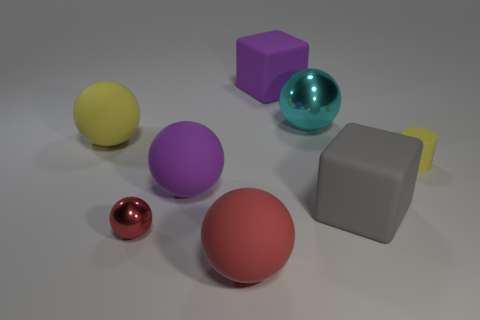Subtract all purple spheres. How many spheres are left? 4 Subtract all red rubber balls. How many balls are left? 4 Add 1 tiny yellow rubber blocks. How many objects exist? 9 Subtract all gray balls. Subtract all yellow cubes. How many balls are left? 5 Subtract all spheres. How many objects are left? 3 Add 3 gray blocks. How many gray blocks are left? 4 Add 7 yellow balls. How many yellow balls exist? 8 Subtract 0 green cylinders. How many objects are left? 8 Subtract all small yellow rubber things. Subtract all red balls. How many objects are left? 5 